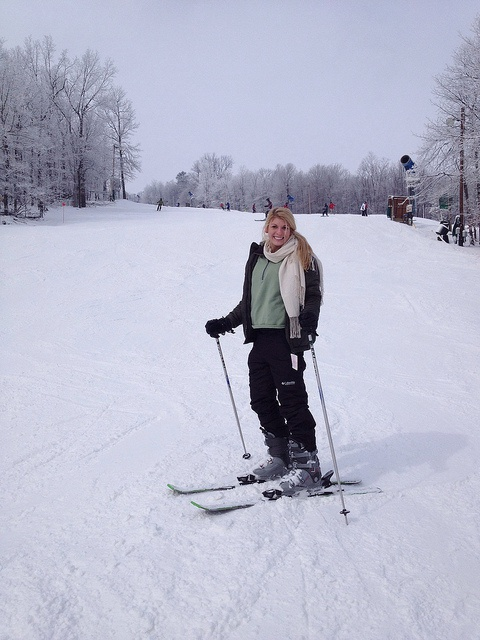Describe the objects in this image and their specific colors. I can see people in lavender, black, gray, and darkgray tones, skis in lavender, darkgray, and gray tones, people in lavender, gray, and black tones, people in lavender, black, darkgray, and gray tones, and people in lavender, gray, black, and darkgray tones in this image. 